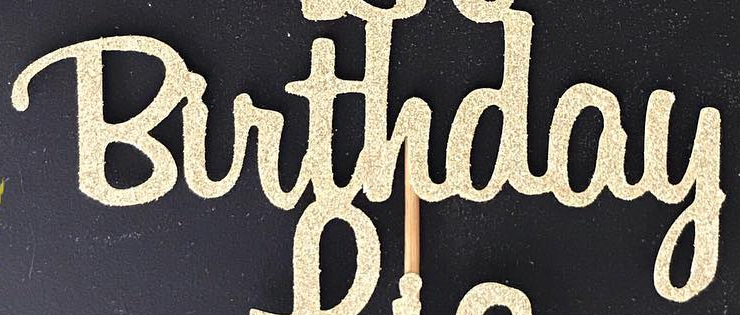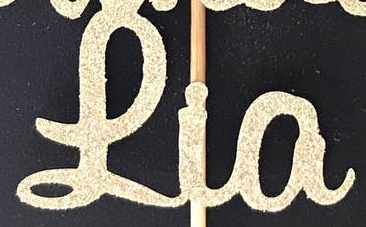Read the text content from these images in order, separated by a semicolon. Birthday; Lia 